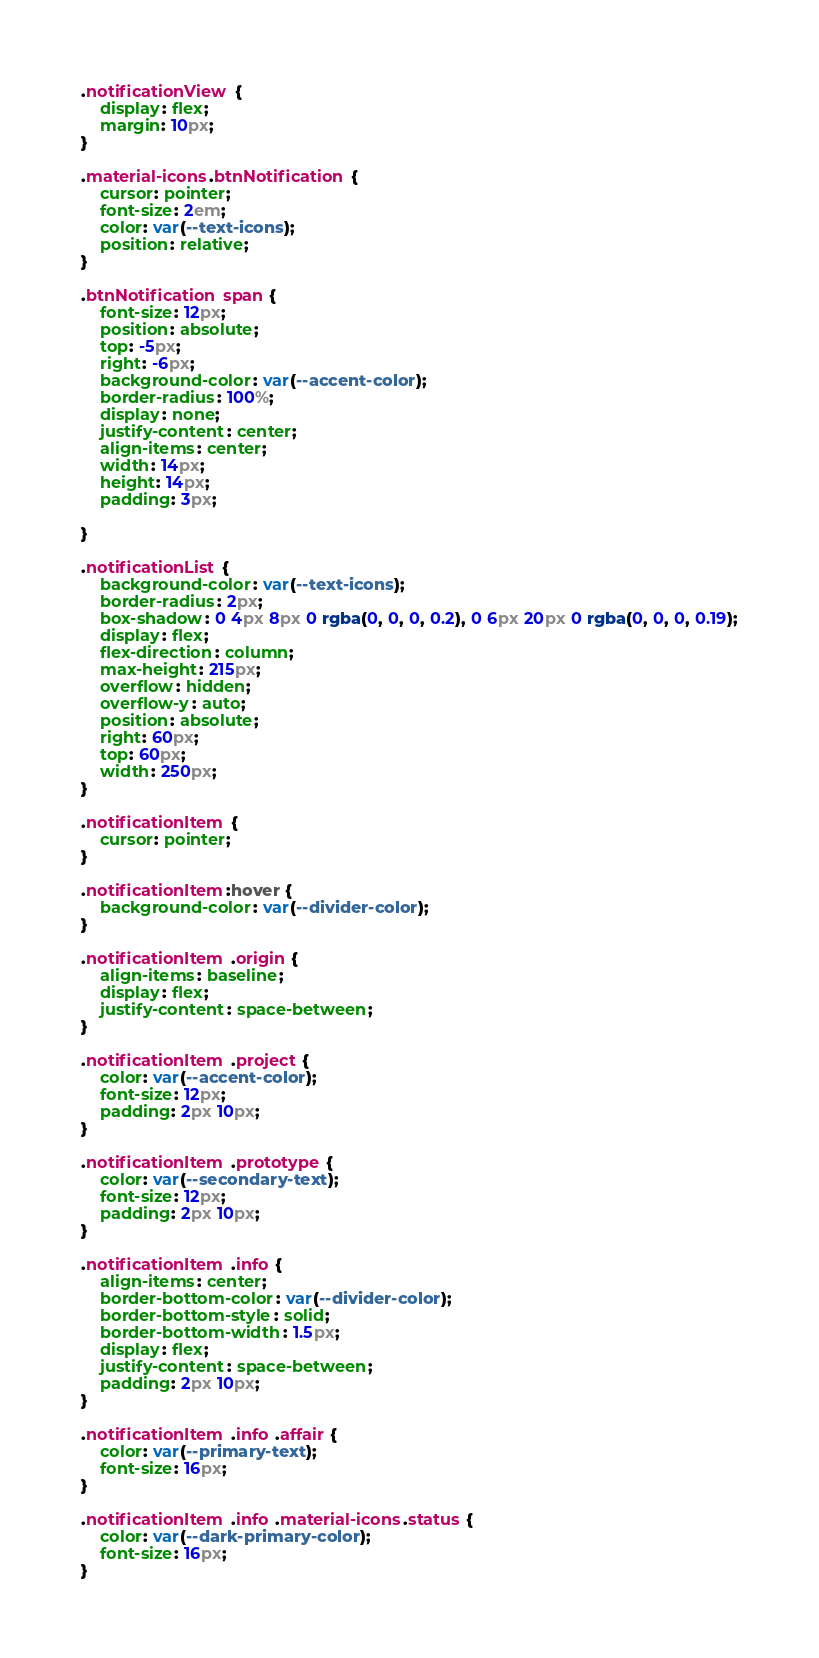Convert code to text. <code><loc_0><loc_0><loc_500><loc_500><_CSS_>.notificationView {
    display: flex;
    margin: 10px;
}

.material-icons.btnNotification {
    cursor: pointer;
    font-size: 2em;
    color: var(--text-icons);
    position: relative;
}

.btnNotification span {
    font-size: 12px;
    position: absolute;
    top: -5px;
    right: -6px;
    background-color: var(--accent-color);
    border-radius: 100%;
    display: none;
    justify-content: center;
    align-items: center;
    width: 14px;
    height: 14px;
    padding: 3px;

}

.notificationList {
    background-color: var(--text-icons);
    border-radius: 2px;
    box-shadow: 0 4px 8px 0 rgba(0, 0, 0, 0.2), 0 6px 20px 0 rgba(0, 0, 0, 0.19);
    display: flex;
    flex-direction: column;
    max-height: 215px;
    overflow: hidden;
    overflow-y: auto;
    position: absolute;
    right: 60px;
    top: 60px;
    width: 250px;
}

.notificationItem {
    cursor: pointer;
}

.notificationItem:hover {
    background-color: var(--divider-color);
}

.notificationItem .origin {
    align-items: baseline;
    display: flex;
    justify-content: space-between;
}

.notificationItem .project {
    color: var(--accent-color);
    font-size: 12px;
    padding: 2px 10px;
}

.notificationItem .prototype {
    color: var(--secondary-text);
    font-size: 12px;
    padding: 2px 10px;
}

.notificationItem .info {
    align-items: center;
    border-bottom-color: var(--divider-color);
    border-bottom-style: solid;
    border-bottom-width: 1.5px;
    display: flex;
    justify-content: space-between;
    padding: 2px 10px;
}

.notificationItem .info .affair {
    color: var(--primary-text);
    font-size: 16px;
}

.notificationItem .info .material-icons.status {
    color: var(--dark-primary-color);
    font-size: 16px;
}</code> 